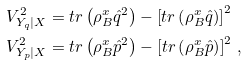<formula> <loc_0><loc_0><loc_500><loc_500>V _ { Y _ { q } | X } ^ { 2 } & = t r \left ( \rho _ { B } ^ { x } \hat { q } ^ { 2 } \right ) - \left [ t r \left ( \rho _ { B } ^ { x } \hat { q } \right ) \right ] ^ { 2 } \\ V _ { Y _ { p } | X } ^ { 2 } & = t r \left ( \rho _ { B } ^ { x } \hat { p } ^ { 2 } \right ) - \left [ t r \left ( \rho _ { B } ^ { x } \hat { p } \right ) \right ] ^ { 2 } \, , \\</formula> 